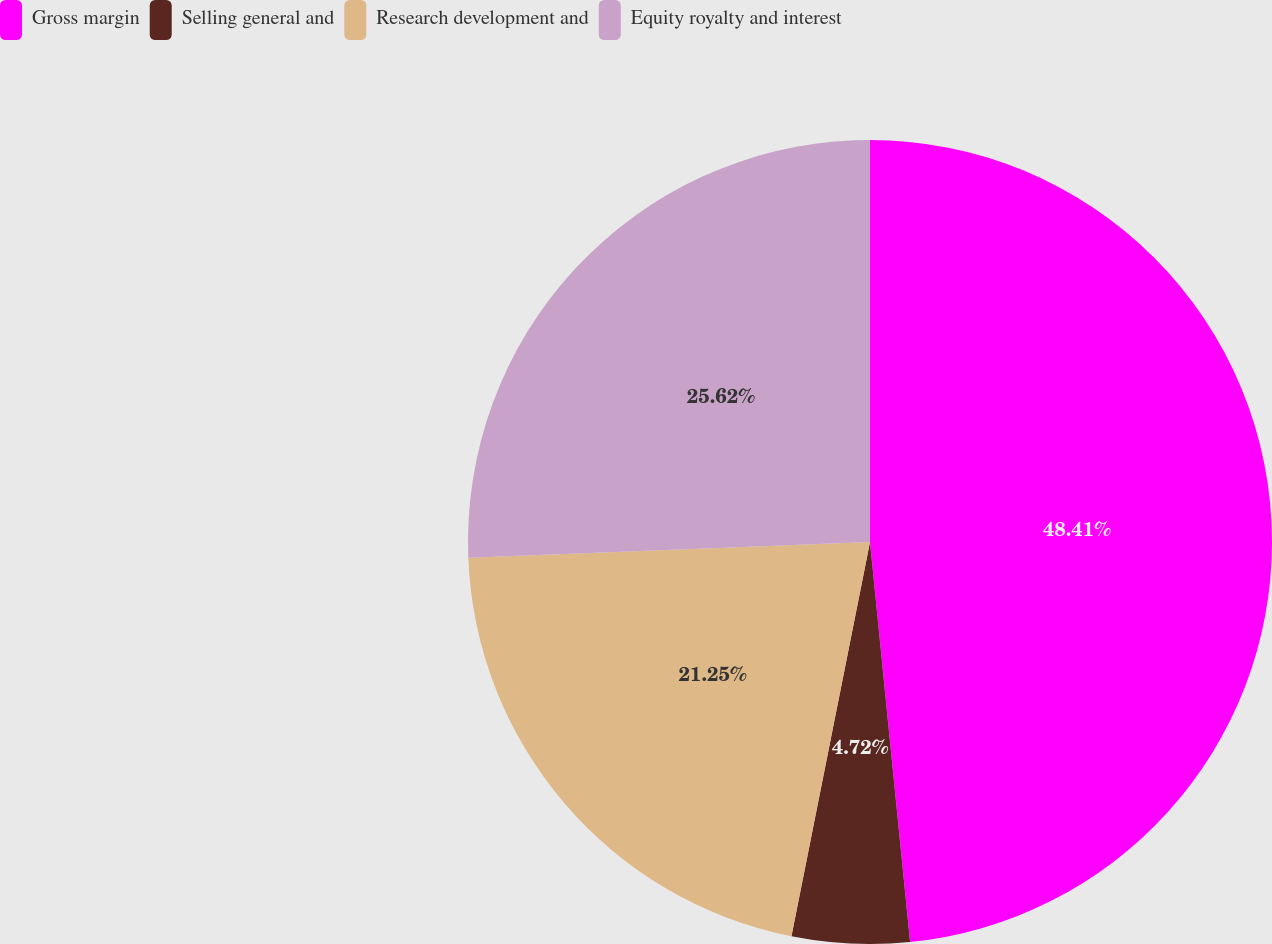Convert chart. <chart><loc_0><loc_0><loc_500><loc_500><pie_chart><fcel>Gross margin<fcel>Selling general and<fcel>Research development and<fcel>Equity royalty and interest<nl><fcel>48.41%<fcel>4.72%<fcel>21.25%<fcel>25.62%<nl></chart> 